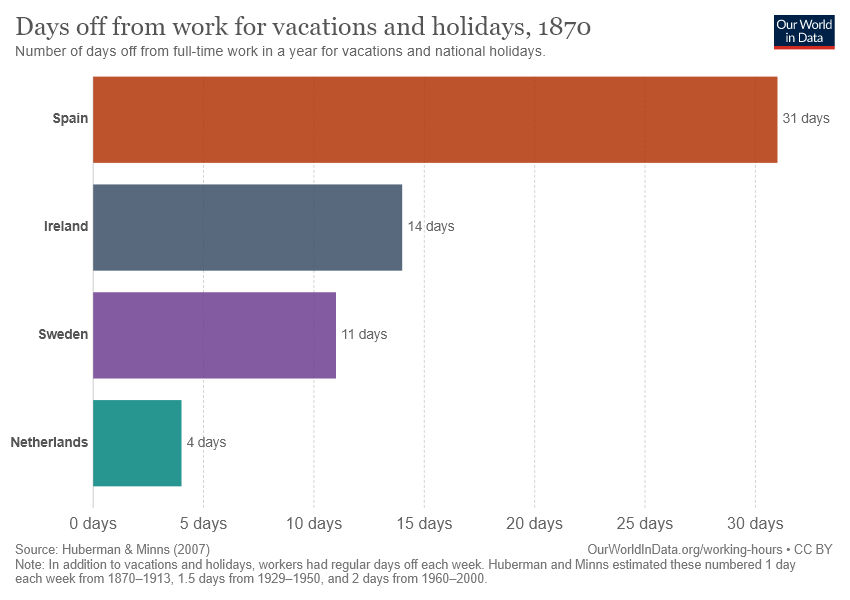List a handful of essential elements in this visual. On average, the combined length of all bars is 15 days. 